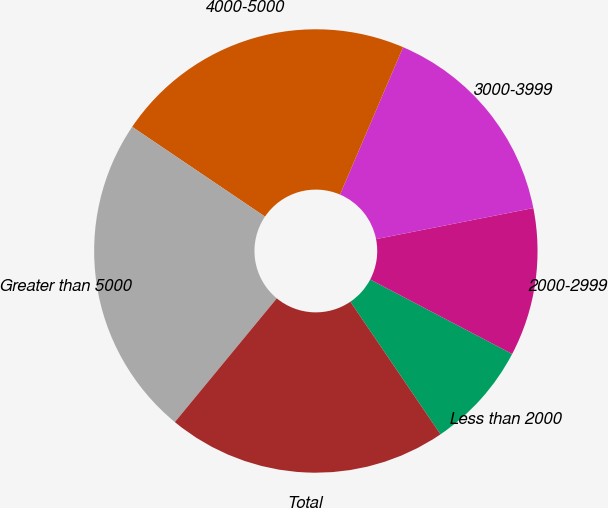Convert chart. <chart><loc_0><loc_0><loc_500><loc_500><pie_chart><fcel>Less than 2000<fcel>2000-2999<fcel>3000-3999<fcel>4000-5000<fcel>Greater than 5000<fcel>Total<nl><fcel>7.81%<fcel>10.79%<fcel>15.46%<fcel>21.98%<fcel>23.49%<fcel>20.47%<nl></chart> 